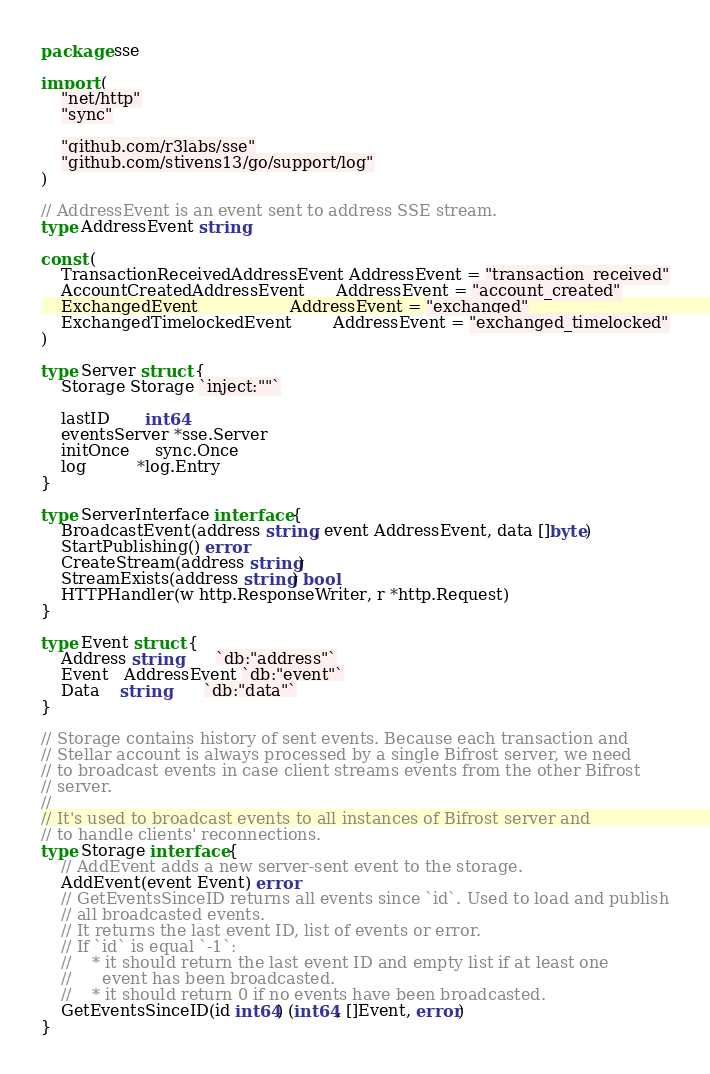Convert code to text. <code><loc_0><loc_0><loc_500><loc_500><_Go_>package sse

import (
	"net/http"
	"sync"

	"github.com/r3labs/sse"
	"github.com/stivens13/go/support/log"
)

// AddressEvent is an event sent to address SSE stream.
type AddressEvent string

const (
	TransactionReceivedAddressEvent AddressEvent = "transaction_received"
	AccountCreatedAddressEvent      AddressEvent = "account_created"
	ExchangedEvent                  AddressEvent = "exchanged"
	ExchangedTimelockedEvent        AddressEvent = "exchanged_timelocked"
)

type Server struct {
	Storage Storage `inject:""`

	lastID       int64
	eventsServer *sse.Server
	initOnce     sync.Once
	log          *log.Entry
}

type ServerInterface interface {
	BroadcastEvent(address string, event AddressEvent, data []byte)
	StartPublishing() error
	CreateStream(address string)
	StreamExists(address string) bool
	HTTPHandler(w http.ResponseWriter, r *http.Request)
}

type Event struct {
	Address string       `db:"address"`
	Event   AddressEvent `db:"event"`
	Data    string       `db:"data"`
}

// Storage contains history of sent events. Because each transaction and
// Stellar account is always processed by a single Bifrost server, we need
// to broadcast events in case client streams events from the other Bifrost
// server.
//
// It's used to broadcast events to all instances of Bifrost server and
// to handle clients' reconnections.
type Storage interface {
	// AddEvent adds a new server-sent event to the storage.
	AddEvent(event Event) error
	// GetEventsSinceID returns all events since `id`. Used to load and publish
	// all broadcasted events.
	// It returns the last event ID, list of events or error.
	// If `id` is equal `-1`:
	//    * it should return the last event ID and empty list if at least one
	//      event has been broadcasted.
	//    * it should return 0 if no events have been broadcasted.
	GetEventsSinceID(id int64) (int64, []Event, error)
}
</code> 